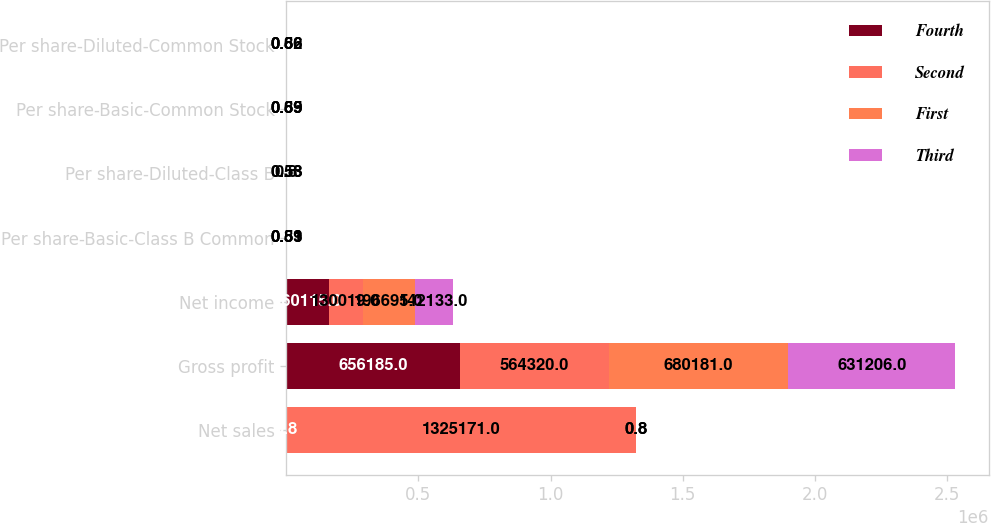<chart> <loc_0><loc_0><loc_500><loc_500><stacked_bar_chart><ecel><fcel>Net sales<fcel>Gross profit<fcel>Net income<fcel>Per share-Basic-Class B Common<fcel>Per share-Diluted-Class B<fcel>Per share-Basic-Common Stock<fcel>Per share-Diluted-Common Stock<nl><fcel>Fourth<fcel>0.8<fcel>656185<fcel>160115<fcel>0.65<fcel>0.65<fcel>0.72<fcel>0.7<nl><fcel>Second<fcel>1.32517e+06<fcel>564320<fcel>130019<fcel>0.53<fcel>0.53<fcel>0.59<fcel>0.56<nl><fcel>First<fcel>0.8<fcel>680181<fcel>196695<fcel>0.81<fcel>0.8<fcel>0.89<fcel>0.86<nl><fcel>Third<fcel>0.8<fcel>631206<fcel>142133<fcel>0.59<fcel>0.58<fcel>0.65<fcel>0.62<nl></chart> 